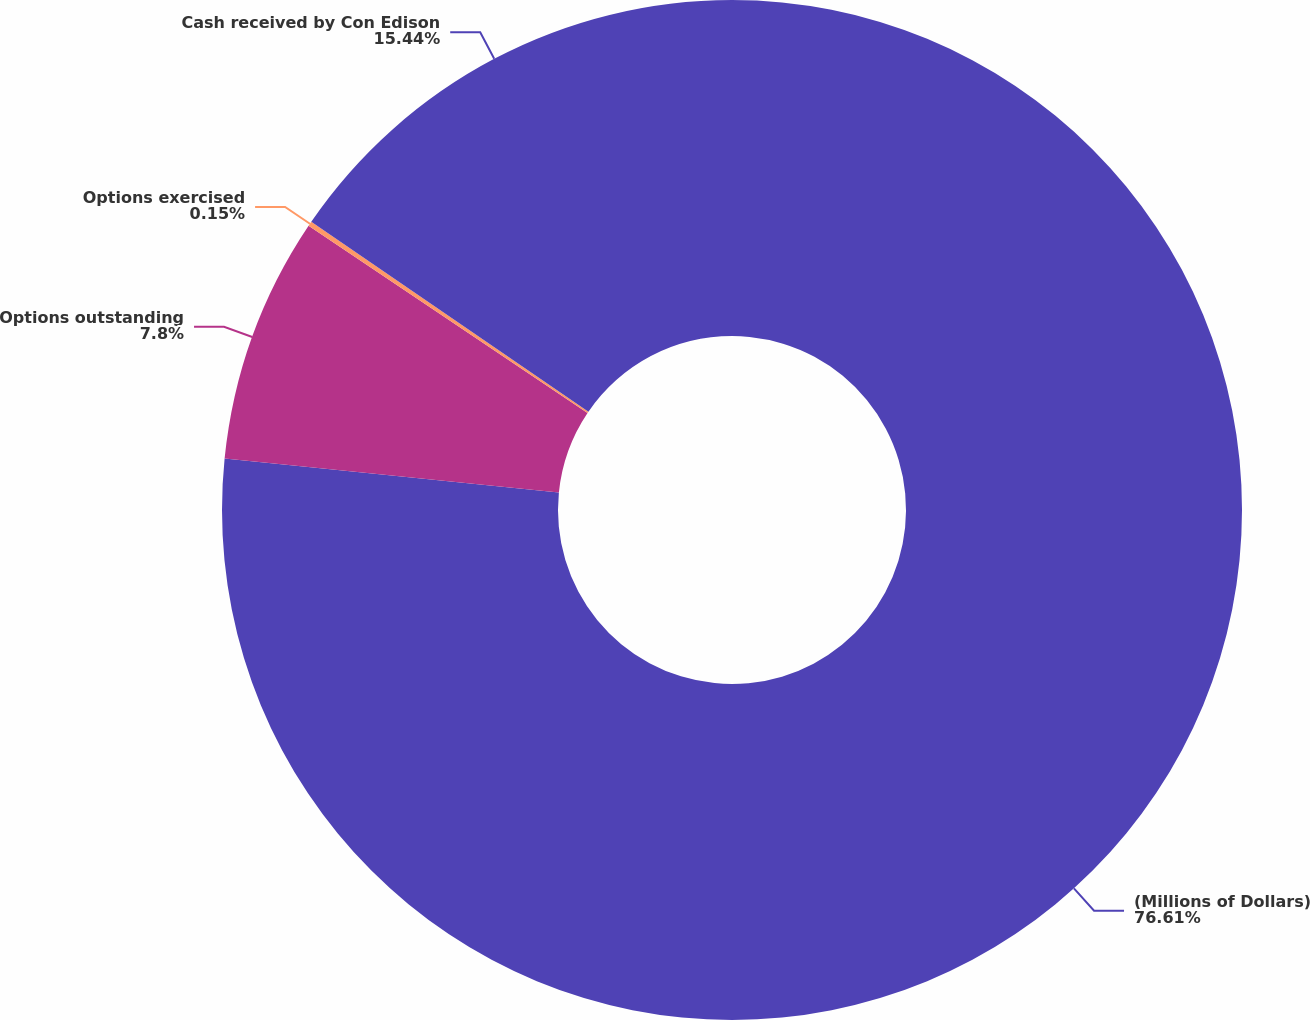Convert chart. <chart><loc_0><loc_0><loc_500><loc_500><pie_chart><fcel>(Millions of Dollars)<fcel>Options outstanding<fcel>Options exercised<fcel>Cash received by Con Edison<nl><fcel>76.61%<fcel>7.8%<fcel>0.15%<fcel>15.44%<nl></chart> 